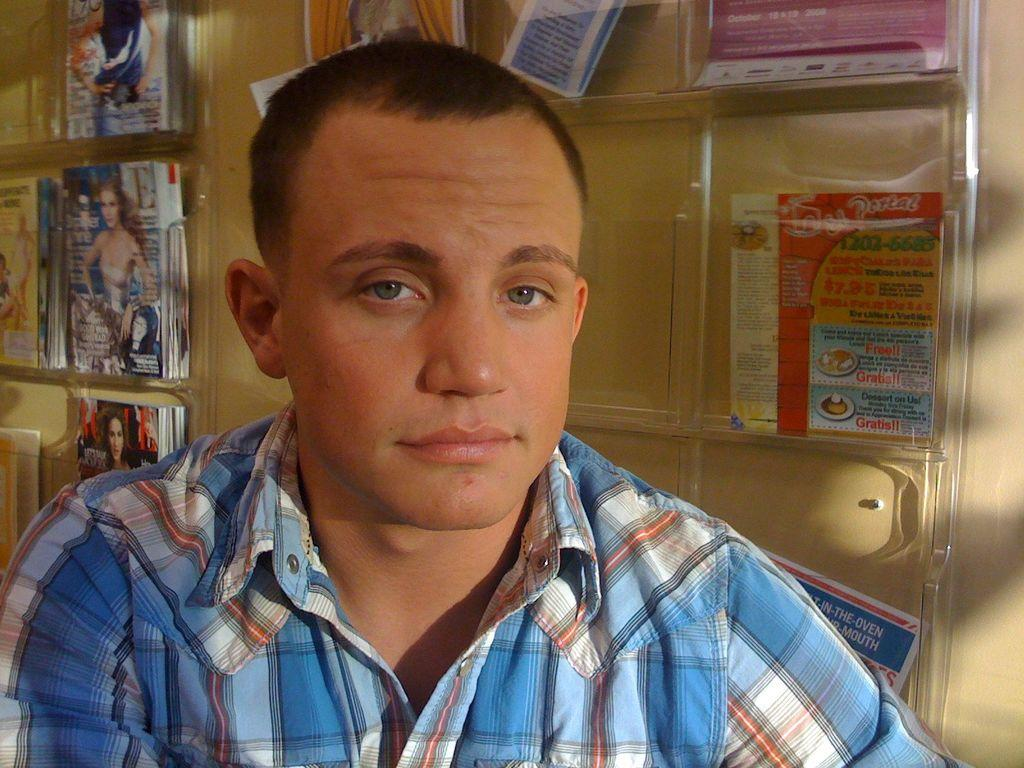Who or what is present in the image? There is a person in the image. What can be observed about the person's attire? The person is wearing clothes. What can be seen in the background of the image? There are flyers and magazines in the background of the image. What type of seat is the person sitting on in the image? There is no seat present in the image; it only shows a person wearing clothes and the background with flyers and magazines. 